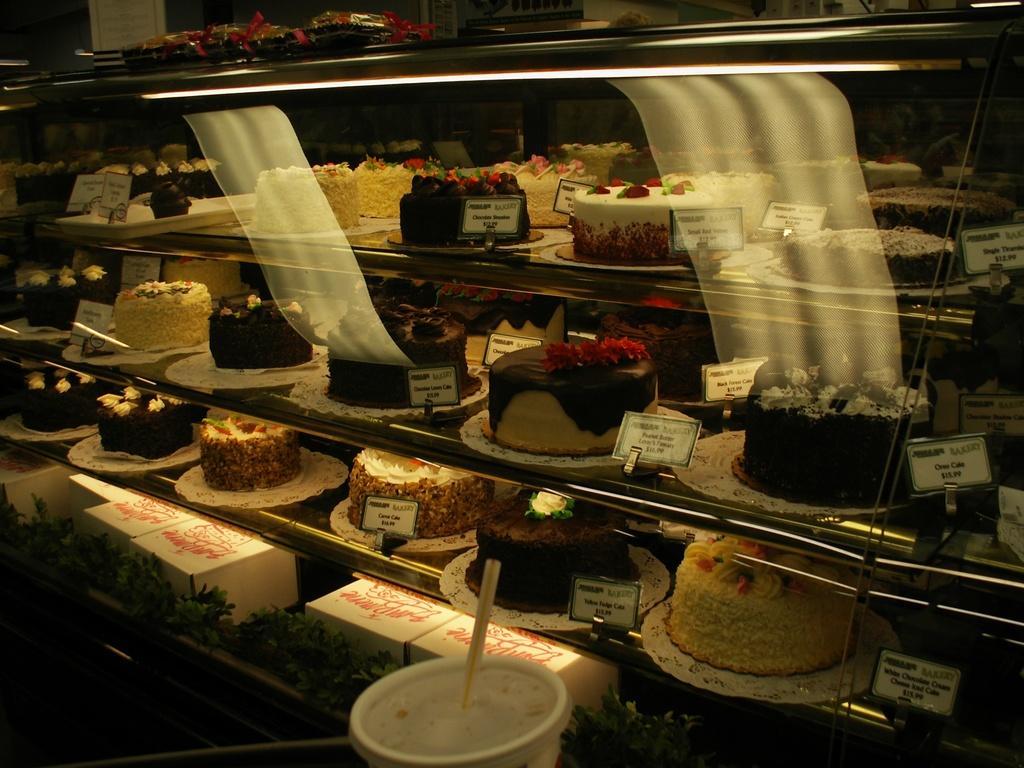Could you give a brief overview of what you see in this image? In this image we can see a rack with cakes, boxes and boards with some text, on the rack, we can see some objects and also we can see a cup with a straw. 